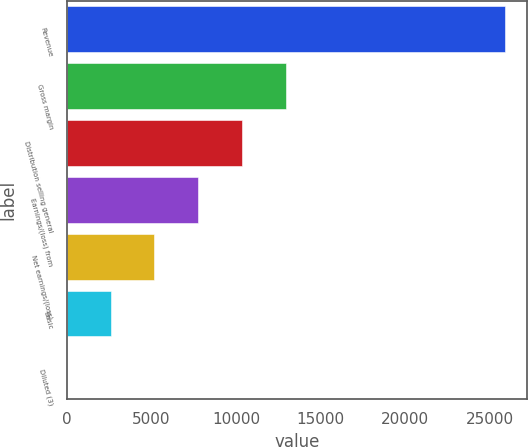Convert chart. <chart><loc_0><loc_0><loc_500><loc_500><bar_chart><fcel>Revenue<fcel>Gross margin<fcel>Distribution selling general<fcel>Earnings/(loss) from<fcel>Net earnings/(loss)<fcel>Basic<fcel>Diluted (3)<nl><fcel>25889<fcel>12944.9<fcel>10356.1<fcel>7767.25<fcel>5178.43<fcel>2589.61<fcel>0.79<nl></chart> 